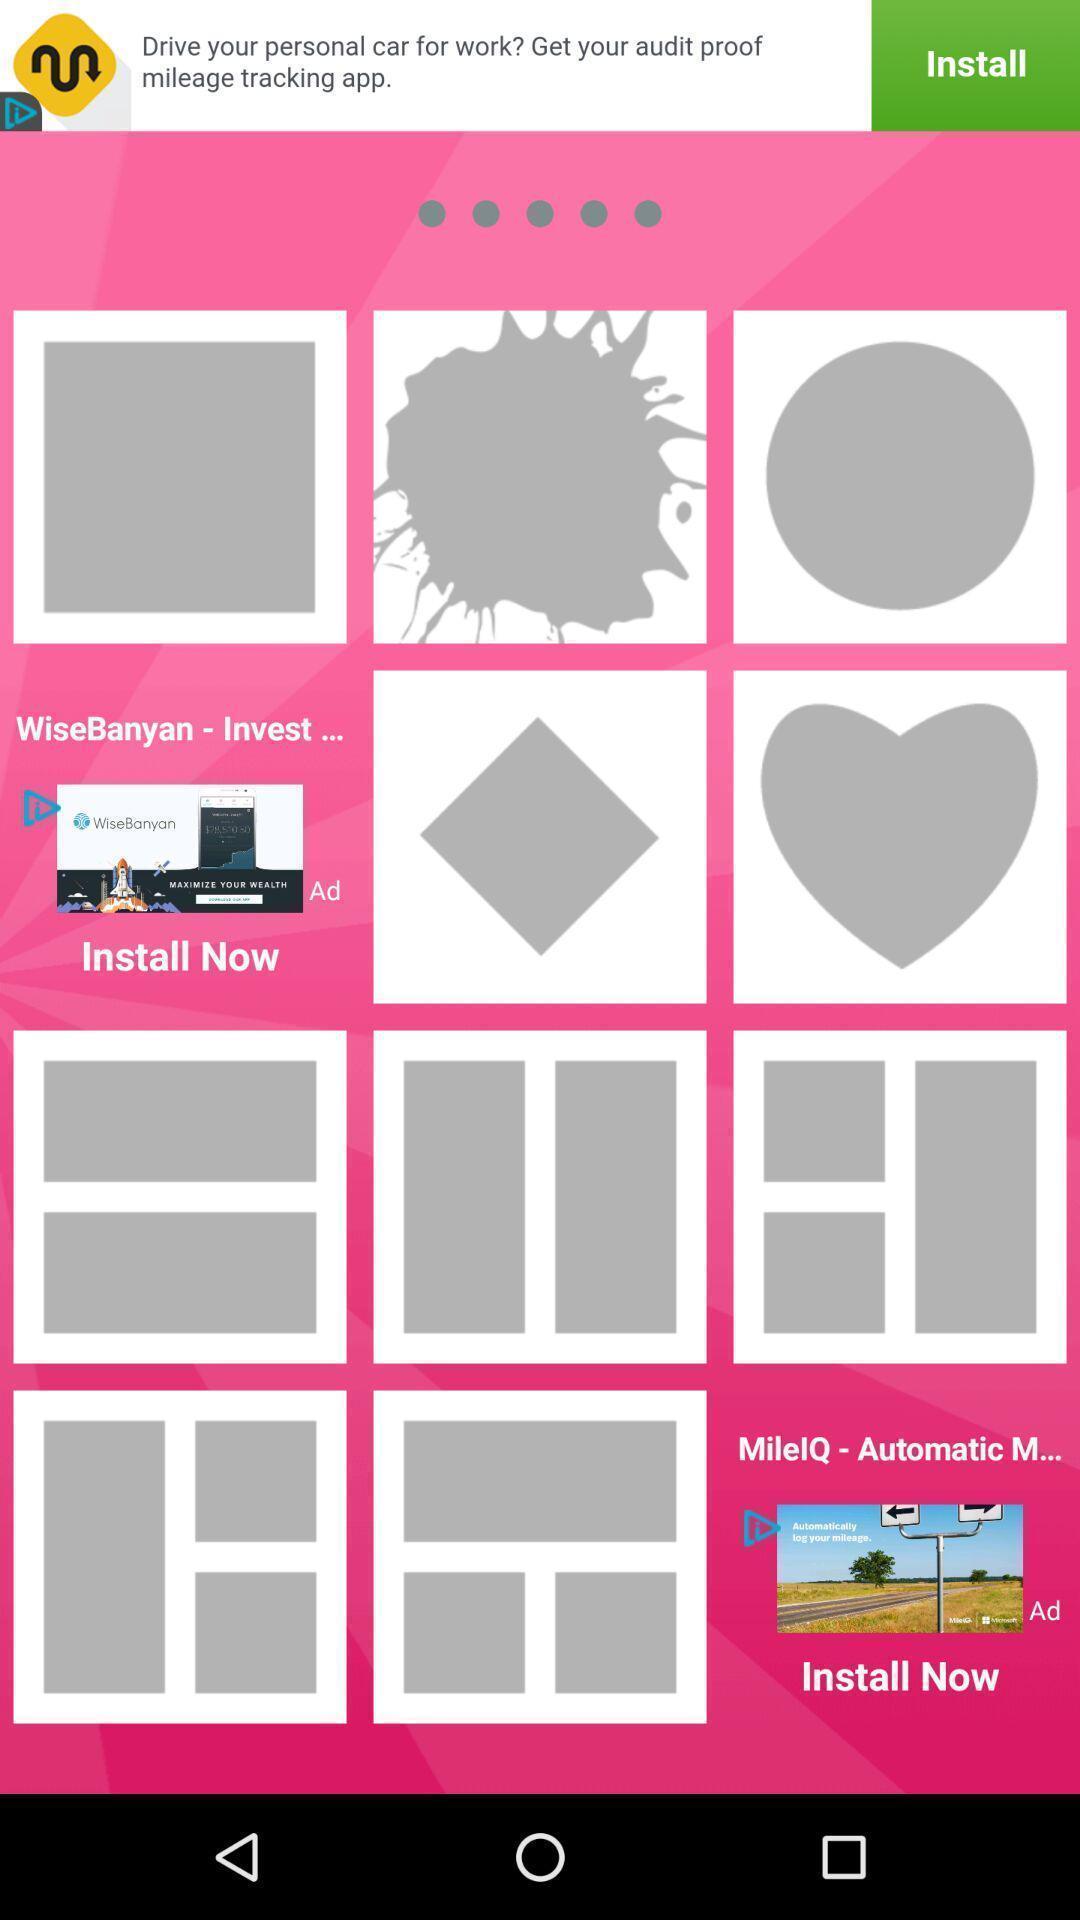What is the overall content of this screenshot? Page showing frames in an editing application. 